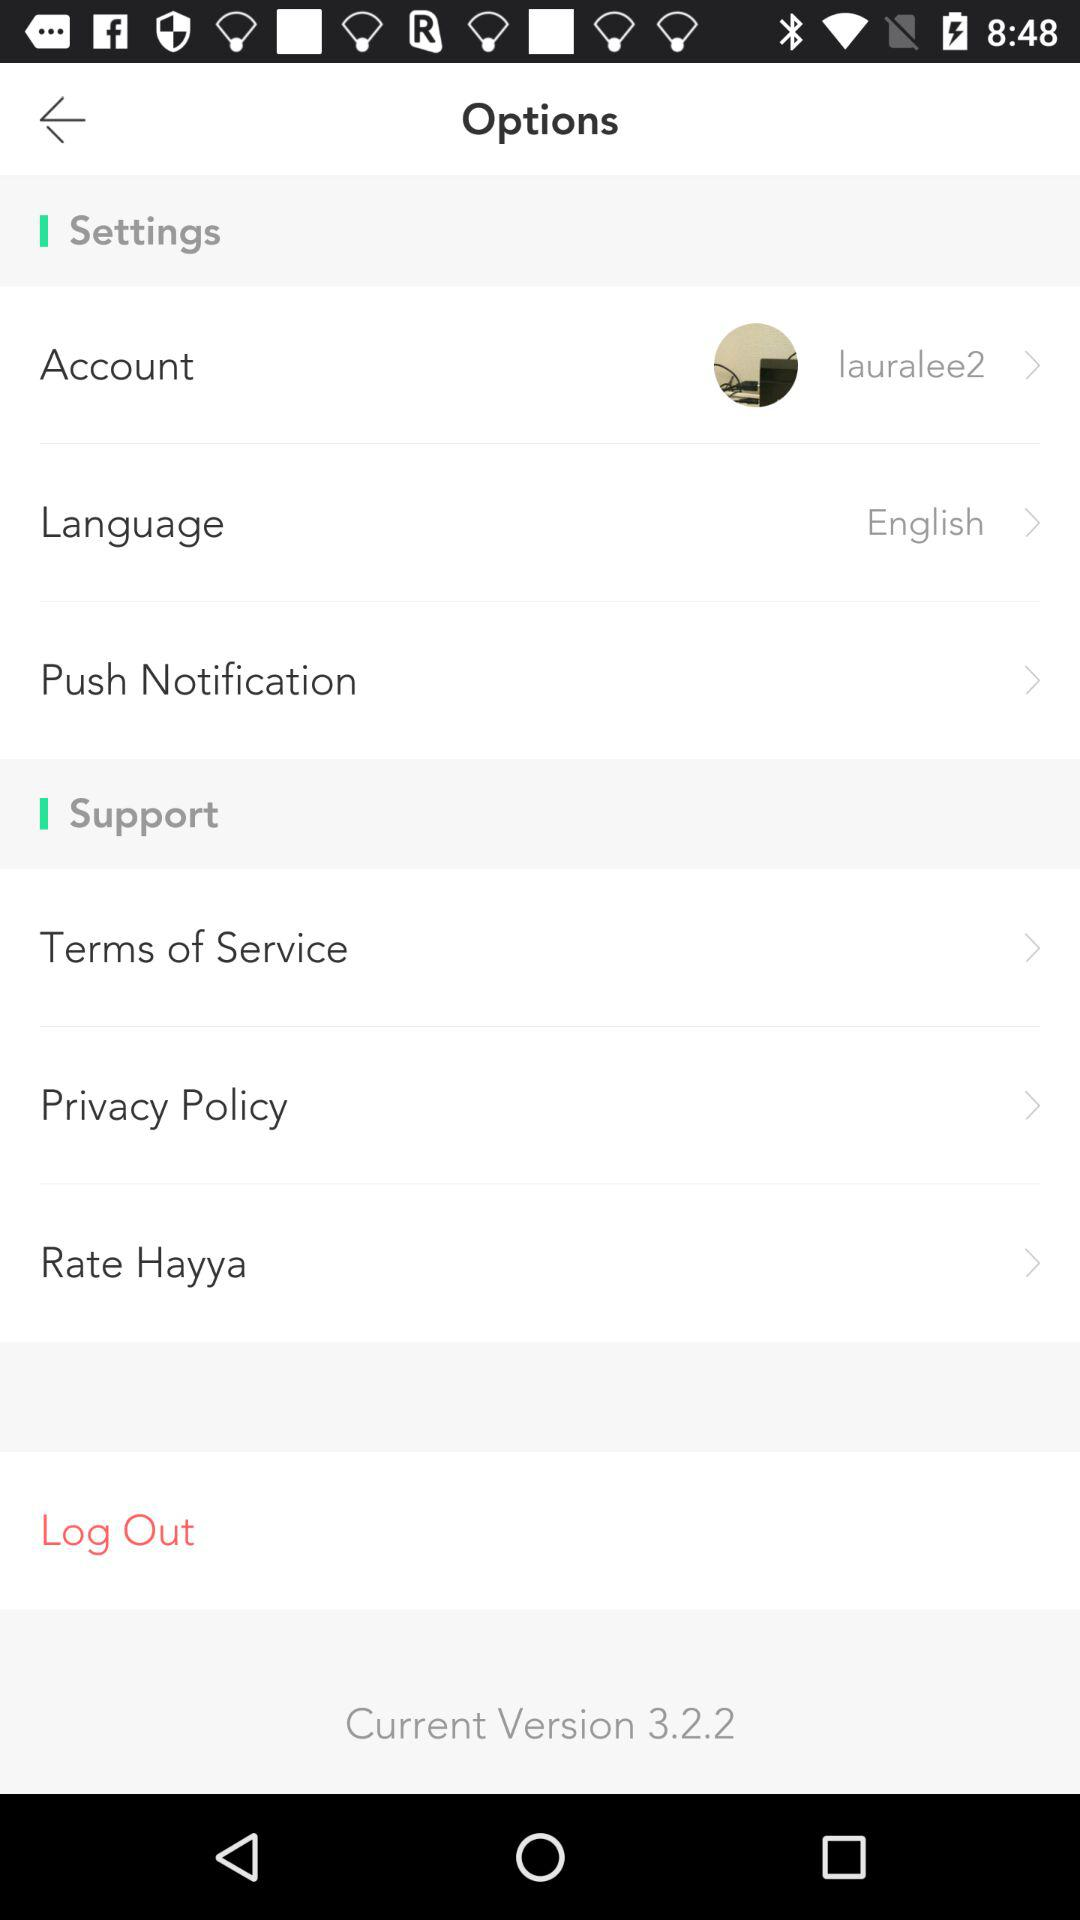What is the status of "Push Notification"?
When the provided information is insufficient, respond with <no answer>. <no answer> 